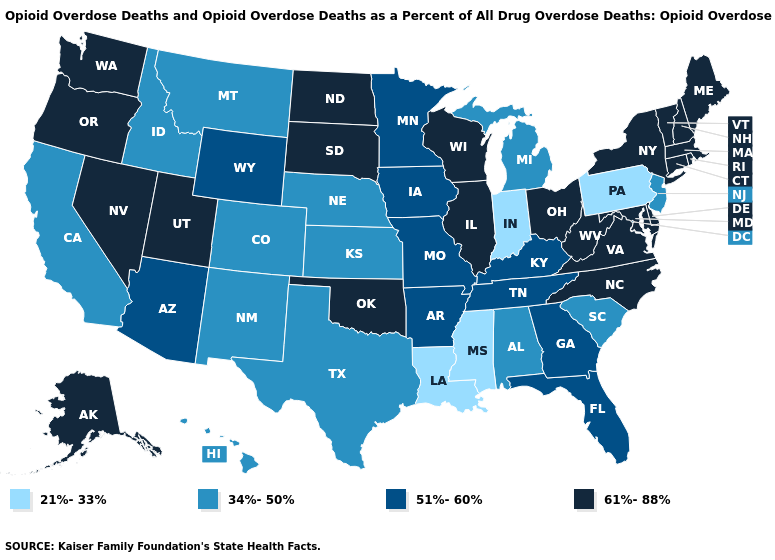What is the value of New Hampshire?
Concise answer only. 61%-88%. What is the lowest value in the USA?
Be succinct. 21%-33%. What is the value of South Dakota?
Concise answer only. 61%-88%. Name the states that have a value in the range 34%-50%?
Write a very short answer. Alabama, California, Colorado, Hawaii, Idaho, Kansas, Michigan, Montana, Nebraska, New Jersey, New Mexico, South Carolina, Texas. How many symbols are there in the legend?
Short answer required. 4. What is the value of Michigan?
Quick response, please. 34%-50%. Which states have the lowest value in the MidWest?
Quick response, please. Indiana. Does Mississippi have a higher value than Nevada?
Short answer required. No. Name the states that have a value in the range 34%-50%?
Short answer required. Alabama, California, Colorado, Hawaii, Idaho, Kansas, Michigan, Montana, Nebraska, New Jersey, New Mexico, South Carolina, Texas. Does Washington have the highest value in the USA?
Concise answer only. Yes. Among the states that border Michigan , does Indiana have the lowest value?
Keep it brief. Yes. Name the states that have a value in the range 21%-33%?
Keep it brief. Indiana, Louisiana, Mississippi, Pennsylvania. What is the value of North Carolina?
Short answer required. 61%-88%. What is the value of Idaho?
Short answer required. 34%-50%. Does Wyoming have the same value as Minnesota?
Keep it brief. Yes. 